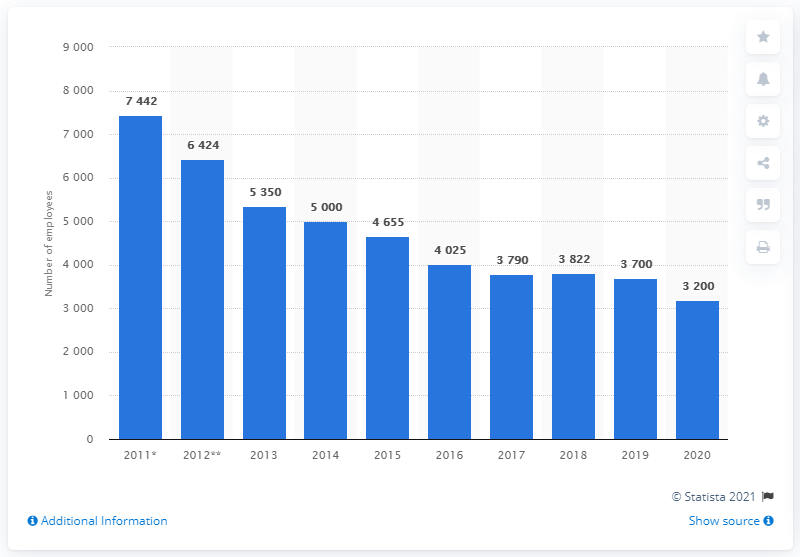Identify some key points in this picture. The fourth shortest bar is 3822...". In 2018, the largest increase in the number of employees was recorded. 